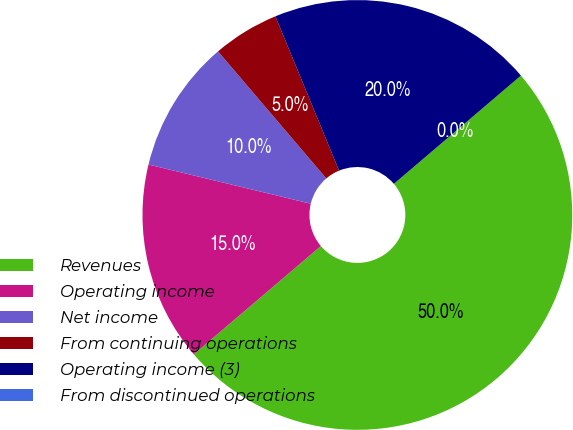<chart> <loc_0><loc_0><loc_500><loc_500><pie_chart><fcel>Revenues<fcel>Operating income<fcel>Net income<fcel>From continuing operations<fcel>Operating income (3)<fcel>From discontinued operations<nl><fcel>50.0%<fcel>15.0%<fcel>10.0%<fcel>5.0%<fcel>20.0%<fcel>0.0%<nl></chart> 